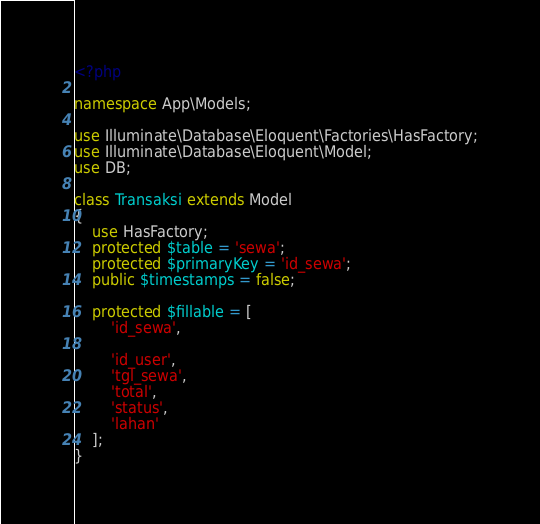<code> <loc_0><loc_0><loc_500><loc_500><_PHP_><?php

namespace App\Models;

use Illuminate\Database\Eloquent\Factories\HasFactory;
use Illuminate\Database\Eloquent\Model;
use DB;

class Transaksi extends Model
{
    use HasFactory;
    protected $table = 'sewa';
    protected $primaryKey = 'id_sewa';
    public $timestamps = false;

    protected $fillable = [
        'id_sewa',
        
        'id_user',
        'tgl_sewa',
        'total',
        'status',
        'lahan'
    ];
}
</code> 